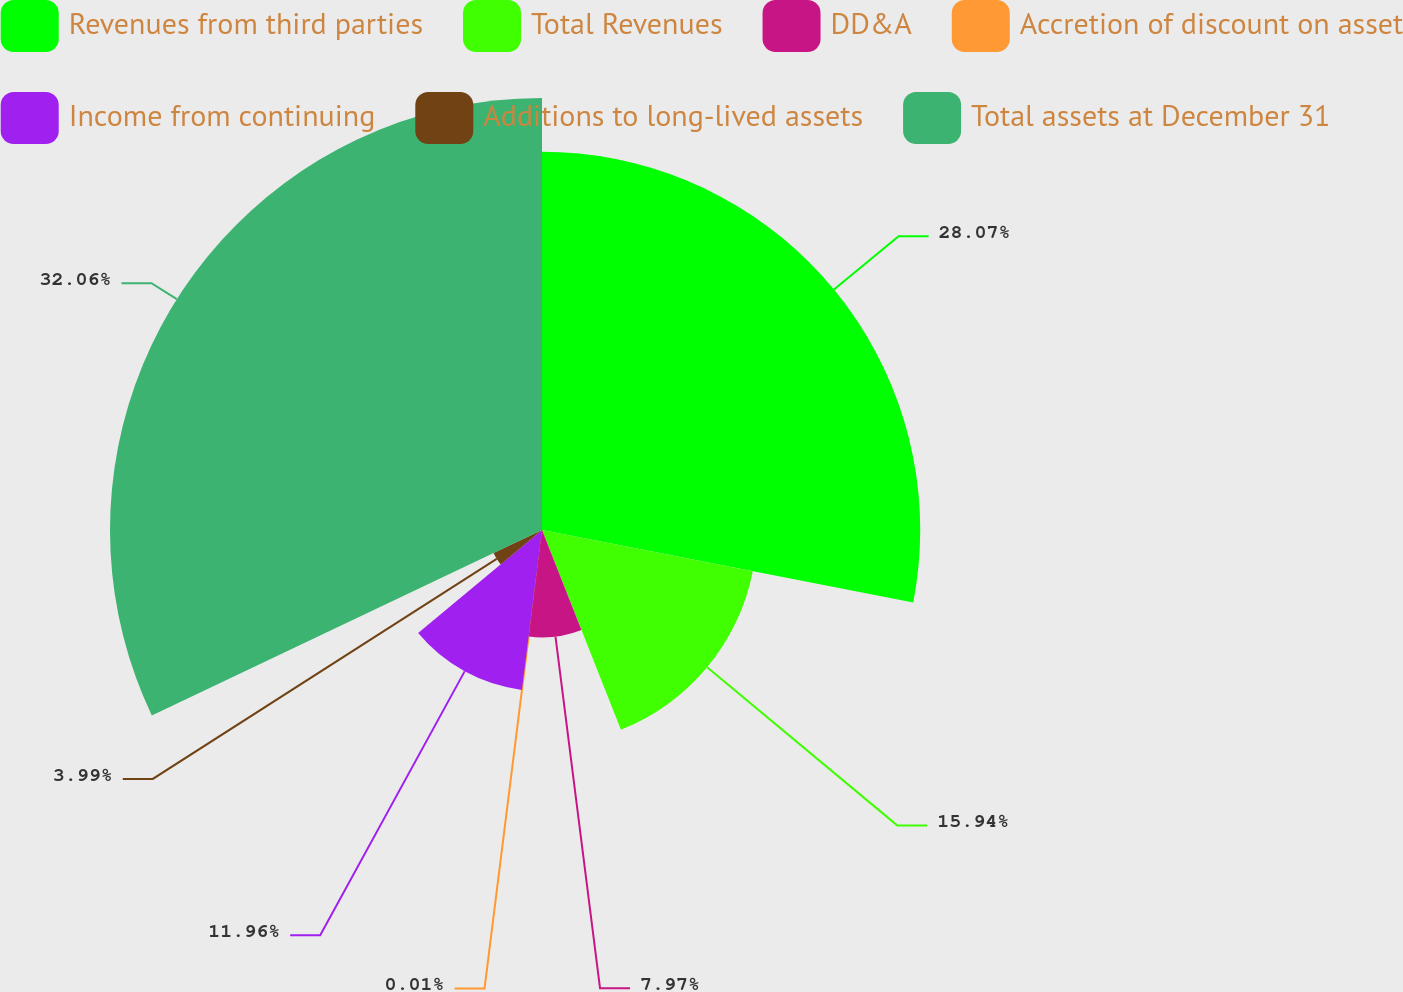Convert chart to OTSL. <chart><loc_0><loc_0><loc_500><loc_500><pie_chart><fcel>Revenues from third parties<fcel>Total Revenues<fcel>DD&A<fcel>Accretion of discount on asset<fcel>Income from continuing<fcel>Additions to long-lived assets<fcel>Total assets at December 31<nl><fcel>28.07%<fcel>15.94%<fcel>7.97%<fcel>0.01%<fcel>11.96%<fcel>3.99%<fcel>32.06%<nl></chart> 